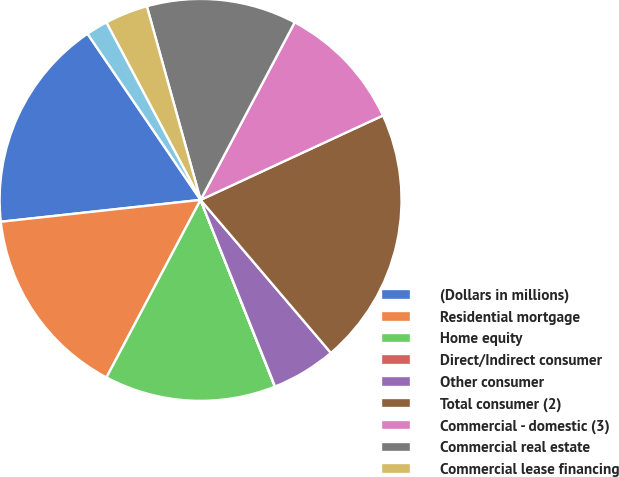Convert chart to OTSL. <chart><loc_0><loc_0><loc_500><loc_500><pie_chart><fcel>(Dollars in millions)<fcel>Residential mortgage<fcel>Home equity<fcel>Direct/Indirect consumer<fcel>Other consumer<fcel>Total consumer (2)<fcel>Commercial - domestic (3)<fcel>Commercial real estate<fcel>Commercial lease financing<fcel>Commercial - foreign<nl><fcel>17.22%<fcel>15.5%<fcel>13.78%<fcel>0.02%<fcel>5.18%<fcel>20.66%<fcel>10.34%<fcel>12.06%<fcel>3.46%<fcel>1.74%<nl></chart> 